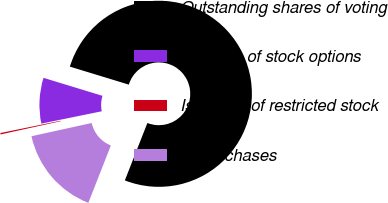Convert chart to OTSL. <chart><loc_0><loc_0><loc_500><loc_500><pie_chart><fcel>Outstanding shares of voting<fcel>Exercise of stock options<fcel>Issuance of restricted stock<fcel>Repurchases<nl><fcel>76.24%<fcel>7.92%<fcel>0.24%<fcel>15.6%<nl></chart> 